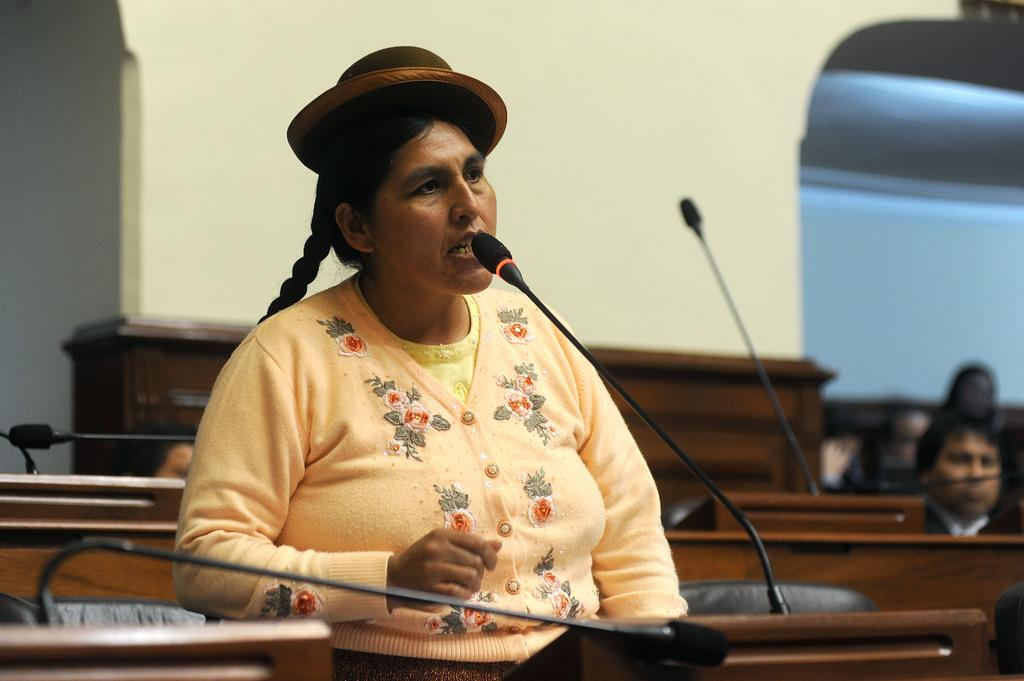What objects can be seen in the foreground of the picture? There are mics and a table in the foreground of the picture. Who is present in the foreground of the picture? A woman is present in the foreground of the picture. What is the woman doing in the picture? The woman is talking. What can be seen in the background of the picture? There are tables, mics, and a wall in the background of the picture. How is the right side of the image described? The right side of the image is blurred. What type of flowers can be seen growing on the wall in the image? There are no flowers present in the image; the wall is in the background, and the image is focused on the woman and the mics. 